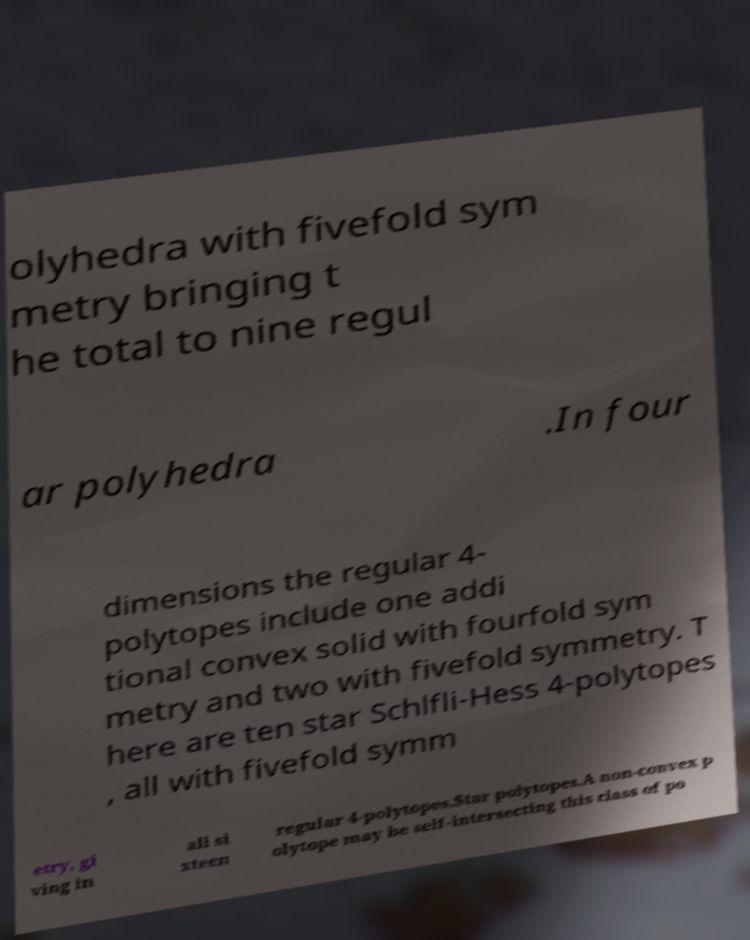Can you accurately transcribe the text from the provided image for me? olyhedra with fivefold sym metry bringing t he total to nine regul ar polyhedra .In four dimensions the regular 4- polytopes include one addi tional convex solid with fourfold sym metry and two with fivefold symmetry. T here are ten star Schlfli-Hess 4-polytopes , all with fivefold symm etry, gi ving in all si xteen regular 4-polytopes.Star polytopes.A non-convex p olytope may be self-intersecting this class of po 